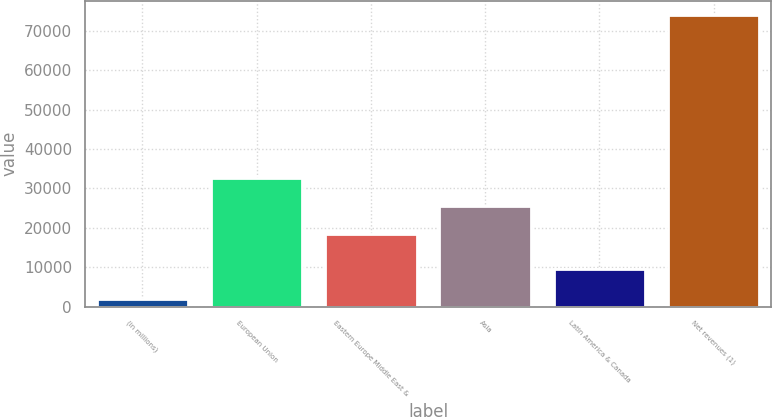Convert chart to OTSL. <chart><loc_0><loc_0><loc_500><loc_500><bar_chart><fcel>(in millions)<fcel>European Union<fcel>Eastern Europe Middle East &<fcel>Asia<fcel>Latin America & Canada<fcel>Net revenues (1)<nl><fcel>2015<fcel>32706.6<fcel>18328<fcel>25517.3<fcel>9548<fcel>73908<nl></chart> 